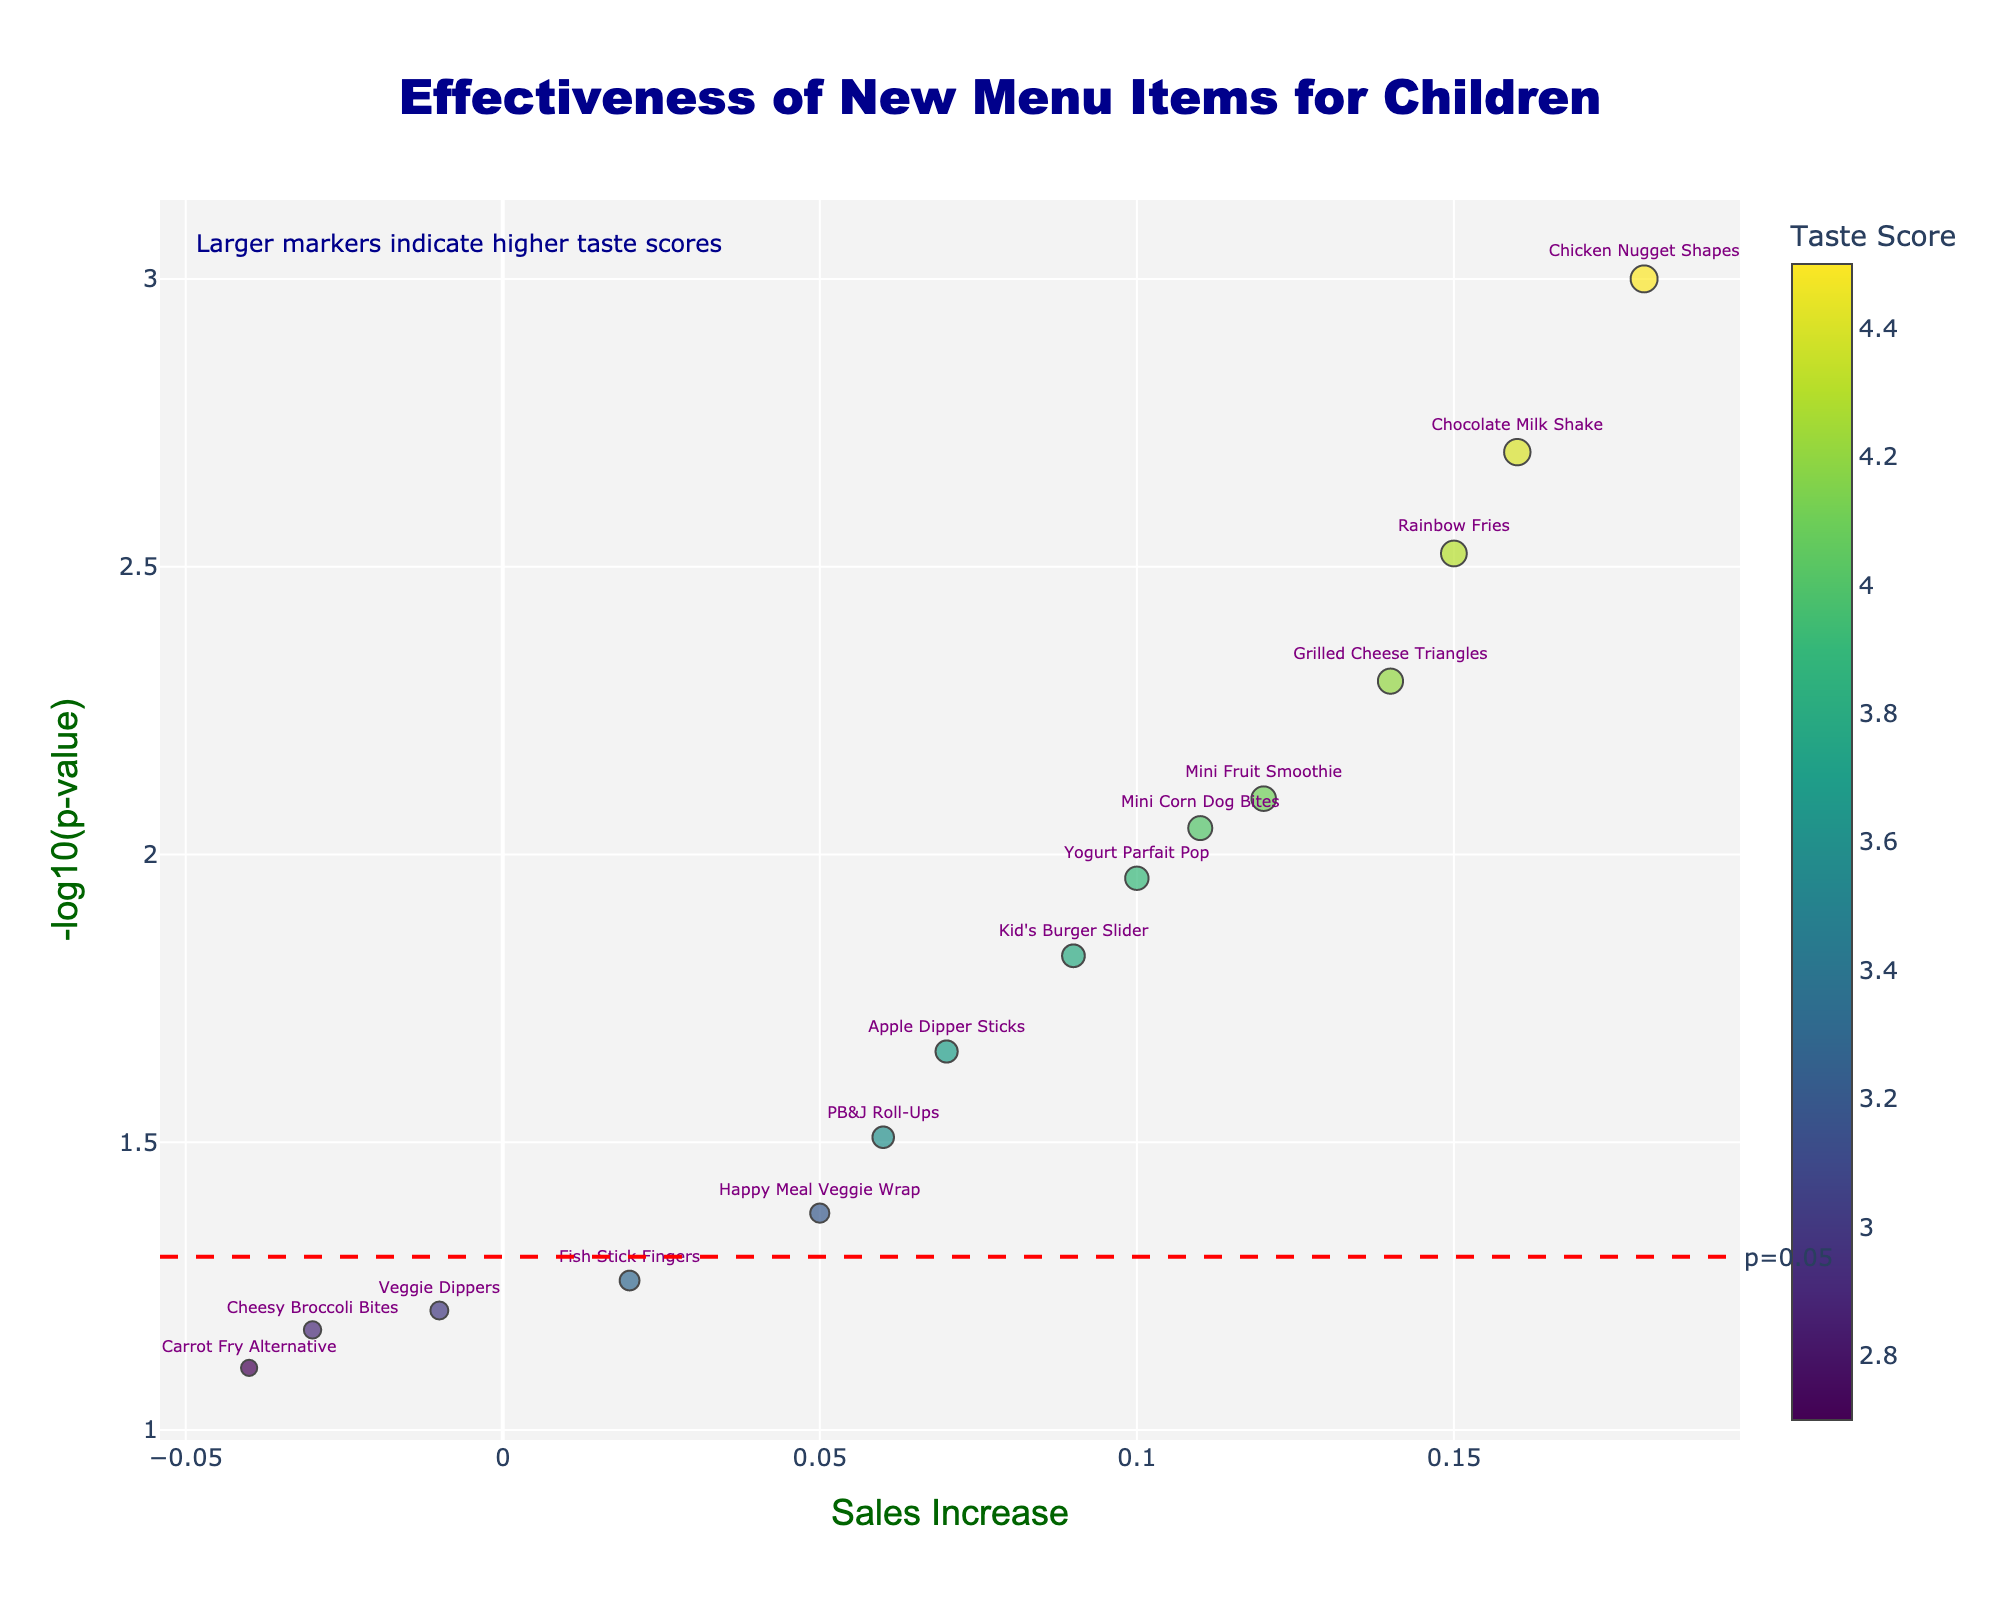What is the significance threshold line indicated in the figure? The figure shows a red dashed line with the annotation "p=0.05". This line represents the significance threshold for p-values, corresponding to y=-log10(0.05).
Answer: p=0.05 Which menu item has the highest taste score on the plot? The color bar indicates taste score, and the marker colors range. A close look at the colored markers shows that "Chicken Nugget Shapes" has the highest taste score.
Answer: Chicken Nugget Shapes How many items have a negative sales increase? To determine this, look at the left side of the vertical axis (x < 0). There are three menu items: "Cheesy Broccoli Bites," "Carrot Fry Alternative," and "Veggie Dippers."
Answer: 3 Which data point has the smallest p-value, and what is its sales increase? The smallest p-value corresponds to the highest y-value in the plot (-log10(p-value)). "Chicken Nugget Shapes" has the highest y-value, indicating it has the smallest p-value. Its sales increase is 0.18.
Answer: Chicken Nugget Shapes, 0.18 Comparing "Rainbow Fries" and "Chocolate Milk Shake," which has a higher taste score and by how much? Both items have high taste scores, reflected by the larger marker size and color intensity. By examining their positions and the color bar, "Chocolate Milk Shake" has a slightly higher taste score of 4.4 compared to "Rainbow Fries," which has 4.3. The difference is 0.1.
Answer: Chocolate Milk Shake, 0.1 Which menu item shows the highest increase in sales among those below the significance threshold? First, identify the items below the significance threshold (y < -log10(0.05)), then compare their x-values (sales increase). "Kid’s Burger Slider" has the highest sales increase of 0.09 among these items.
Answer: Kid's Burger Slider Which item has a medium taste score and a moderate increase in sales, both above the significance threshold? By examining the markers around the middle of the taste score range and sales increase, "Mini Corn Dog Bites" stands out. It has a taste score around 4.0 and sales increase of 0.11, also above the y-threshold of -log10(0.05).
Answer: Mini Corn Dog Bites 